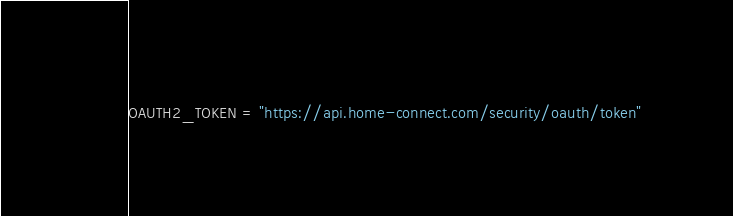<code> <loc_0><loc_0><loc_500><loc_500><_Python_>OAUTH2_TOKEN = "https://api.home-connect.com/security/oauth/token"
</code> 